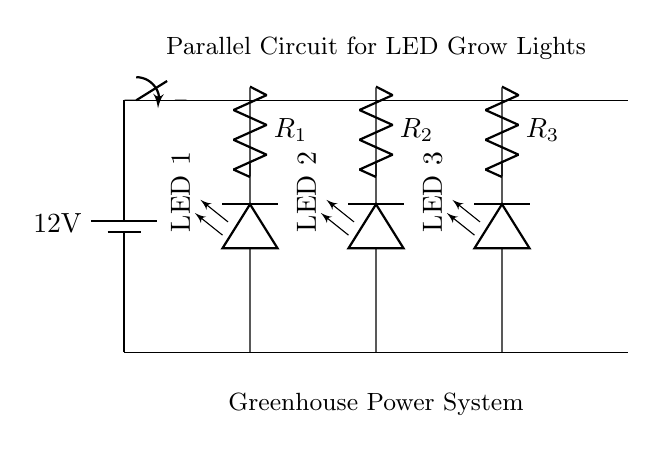What is the power source voltage? The power source voltage is indicated on the battery symbol in the circuit diagram, which shows a value of 12 volts.
Answer: 12 volts How many LED grow lights are in the circuit? The circuit diagram displays three LED grow lights, labeled sequentially from left to right as LED 1, LED 2, and LED 3.
Answer: Three What is the function of the resistors in this circuit? The resistors are used to limit the current flowing through each LED grow light to prevent them from drawing too much current, which could damage them.
Answer: Limit current Is the circuit series or parallel? The circuit is classified as a parallel circuit because each component (LED and resistors) is connected across the same two voltage points, allowing independent operation.
Answer: Parallel What happens if one LED fails? In a parallel circuit, if one LED fails, the other LEDs will continue to function because they are connected in separate branches and do not rely on each other for current flow.
Answer: Others continue functioning What is the role of the switch in this circuit? The switch acts as an on/off control for the entire circuit, allowing the operator to control the power supply to all the LED grow lights simultaneously.
Answer: Control power supply 